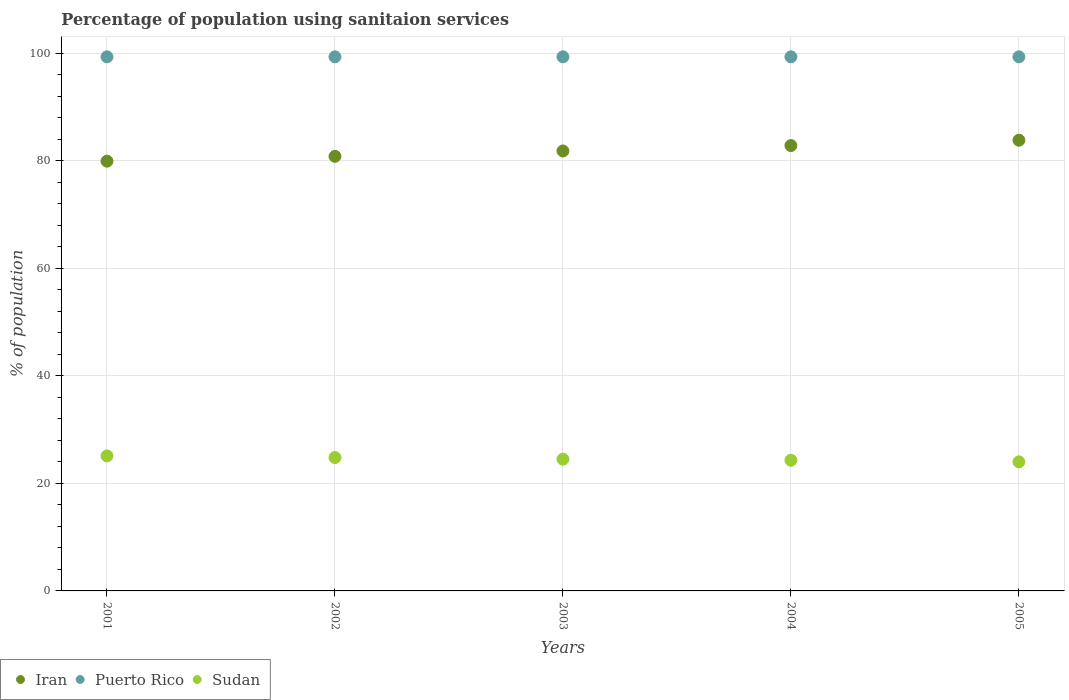Is the number of dotlines equal to the number of legend labels?
Offer a terse response. Yes. What is the percentage of population using sanitaion services in Iran in 2002?
Keep it short and to the point. 80.8. Across all years, what is the maximum percentage of population using sanitaion services in Puerto Rico?
Your response must be concise. 99.3. Across all years, what is the minimum percentage of population using sanitaion services in Puerto Rico?
Provide a short and direct response. 99.3. In which year was the percentage of population using sanitaion services in Iran minimum?
Offer a terse response. 2001. What is the total percentage of population using sanitaion services in Iran in the graph?
Keep it short and to the point. 409.1. What is the difference between the percentage of population using sanitaion services in Sudan in 2002 and the percentage of population using sanitaion services in Puerto Rico in 2005?
Provide a succinct answer. -74.5. What is the average percentage of population using sanitaion services in Sudan per year?
Your answer should be compact. 24.54. In how many years, is the percentage of population using sanitaion services in Iran greater than 36 %?
Offer a very short reply. 5. Is the difference between the percentage of population using sanitaion services in Puerto Rico in 2001 and 2002 greater than the difference between the percentage of population using sanitaion services in Iran in 2001 and 2002?
Your response must be concise. Yes. What is the difference between the highest and the lowest percentage of population using sanitaion services in Puerto Rico?
Your answer should be very brief. 0. In how many years, is the percentage of population using sanitaion services in Sudan greater than the average percentage of population using sanitaion services in Sudan taken over all years?
Keep it short and to the point. 2. Is the sum of the percentage of population using sanitaion services in Sudan in 2004 and 2005 greater than the maximum percentage of population using sanitaion services in Puerto Rico across all years?
Provide a succinct answer. No. Is it the case that in every year, the sum of the percentage of population using sanitaion services in Iran and percentage of population using sanitaion services in Puerto Rico  is greater than the percentage of population using sanitaion services in Sudan?
Your response must be concise. Yes. Does the percentage of population using sanitaion services in Sudan monotonically increase over the years?
Offer a very short reply. No. Is the percentage of population using sanitaion services in Puerto Rico strictly less than the percentage of population using sanitaion services in Sudan over the years?
Your answer should be compact. No. What is the difference between two consecutive major ticks on the Y-axis?
Give a very brief answer. 20. How many legend labels are there?
Make the answer very short. 3. What is the title of the graph?
Your answer should be compact. Percentage of population using sanitaion services. Does "Singapore" appear as one of the legend labels in the graph?
Make the answer very short. No. What is the label or title of the X-axis?
Your answer should be compact. Years. What is the label or title of the Y-axis?
Make the answer very short. % of population. What is the % of population in Iran in 2001?
Make the answer very short. 79.9. What is the % of population in Puerto Rico in 2001?
Keep it short and to the point. 99.3. What is the % of population of Sudan in 2001?
Make the answer very short. 25.1. What is the % of population in Iran in 2002?
Ensure brevity in your answer.  80.8. What is the % of population of Puerto Rico in 2002?
Offer a terse response. 99.3. What is the % of population in Sudan in 2002?
Provide a short and direct response. 24.8. What is the % of population in Iran in 2003?
Ensure brevity in your answer.  81.8. What is the % of population of Puerto Rico in 2003?
Your answer should be compact. 99.3. What is the % of population in Sudan in 2003?
Provide a succinct answer. 24.5. What is the % of population in Iran in 2004?
Your answer should be compact. 82.8. What is the % of population of Puerto Rico in 2004?
Your answer should be very brief. 99.3. What is the % of population in Sudan in 2004?
Your answer should be compact. 24.3. What is the % of population of Iran in 2005?
Give a very brief answer. 83.8. What is the % of population of Puerto Rico in 2005?
Provide a succinct answer. 99.3. Across all years, what is the maximum % of population in Iran?
Give a very brief answer. 83.8. Across all years, what is the maximum % of population in Puerto Rico?
Your answer should be compact. 99.3. Across all years, what is the maximum % of population in Sudan?
Offer a very short reply. 25.1. Across all years, what is the minimum % of population of Iran?
Your answer should be very brief. 79.9. Across all years, what is the minimum % of population of Puerto Rico?
Your answer should be compact. 99.3. What is the total % of population of Iran in the graph?
Ensure brevity in your answer.  409.1. What is the total % of population in Puerto Rico in the graph?
Make the answer very short. 496.5. What is the total % of population in Sudan in the graph?
Your answer should be very brief. 122.7. What is the difference between the % of population in Iran in 2001 and that in 2002?
Ensure brevity in your answer.  -0.9. What is the difference between the % of population of Sudan in 2001 and that in 2003?
Offer a terse response. 0.6. What is the difference between the % of population of Iran in 2001 and that in 2004?
Ensure brevity in your answer.  -2.9. What is the difference between the % of population in Puerto Rico in 2001 and that in 2004?
Offer a very short reply. 0. What is the difference between the % of population in Sudan in 2001 and that in 2004?
Your answer should be compact. 0.8. What is the difference between the % of population in Iran in 2001 and that in 2005?
Give a very brief answer. -3.9. What is the difference between the % of population of Puerto Rico in 2001 and that in 2005?
Your answer should be compact. 0. What is the difference between the % of population of Iran in 2002 and that in 2003?
Keep it short and to the point. -1. What is the difference between the % of population of Sudan in 2002 and that in 2003?
Provide a succinct answer. 0.3. What is the difference between the % of population in Puerto Rico in 2002 and that in 2004?
Provide a short and direct response. 0. What is the difference between the % of population in Puerto Rico in 2002 and that in 2005?
Offer a terse response. 0. What is the difference between the % of population of Puerto Rico in 2003 and that in 2004?
Your answer should be compact. 0. What is the difference between the % of population in Iran in 2003 and that in 2005?
Offer a very short reply. -2. What is the difference between the % of population in Puerto Rico in 2003 and that in 2005?
Give a very brief answer. 0. What is the difference between the % of population in Sudan in 2004 and that in 2005?
Ensure brevity in your answer.  0.3. What is the difference between the % of population in Iran in 2001 and the % of population in Puerto Rico in 2002?
Offer a terse response. -19.4. What is the difference between the % of population in Iran in 2001 and the % of population in Sudan in 2002?
Offer a terse response. 55.1. What is the difference between the % of population in Puerto Rico in 2001 and the % of population in Sudan in 2002?
Offer a very short reply. 74.5. What is the difference between the % of population of Iran in 2001 and the % of population of Puerto Rico in 2003?
Give a very brief answer. -19.4. What is the difference between the % of population in Iran in 2001 and the % of population in Sudan in 2003?
Your answer should be compact. 55.4. What is the difference between the % of population of Puerto Rico in 2001 and the % of population of Sudan in 2003?
Ensure brevity in your answer.  74.8. What is the difference between the % of population in Iran in 2001 and the % of population in Puerto Rico in 2004?
Ensure brevity in your answer.  -19.4. What is the difference between the % of population of Iran in 2001 and the % of population of Sudan in 2004?
Ensure brevity in your answer.  55.6. What is the difference between the % of population in Iran in 2001 and the % of population in Puerto Rico in 2005?
Make the answer very short. -19.4. What is the difference between the % of population in Iran in 2001 and the % of population in Sudan in 2005?
Offer a very short reply. 55.9. What is the difference between the % of population in Puerto Rico in 2001 and the % of population in Sudan in 2005?
Keep it short and to the point. 75.3. What is the difference between the % of population of Iran in 2002 and the % of population of Puerto Rico in 2003?
Provide a succinct answer. -18.5. What is the difference between the % of population of Iran in 2002 and the % of population of Sudan in 2003?
Provide a short and direct response. 56.3. What is the difference between the % of population of Puerto Rico in 2002 and the % of population of Sudan in 2003?
Your response must be concise. 74.8. What is the difference between the % of population of Iran in 2002 and the % of population of Puerto Rico in 2004?
Your answer should be compact. -18.5. What is the difference between the % of population in Iran in 2002 and the % of population in Sudan in 2004?
Ensure brevity in your answer.  56.5. What is the difference between the % of population in Iran in 2002 and the % of population in Puerto Rico in 2005?
Your answer should be very brief. -18.5. What is the difference between the % of population of Iran in 2002 and the % of population of Sudan in 2005?
Keep it short and to the point. 56.8. What is the difference between the % of population of Puerto Rico in 2002 and the % of population of Sudan in 2005?
Offer a very short reply. 75.3. What is the difference between the % of population in Iran in 2003 and the % of population in Puerto Rico in 2004?
Your response must be concise. -17.5. What is the difference between the % of population of Iran in 2003 and the % of population of Sudan in 2004?
Ensure brevity in your answer.  57.5. What is the difference between the % of population of Iran in 2003 and the % of population of Puerto Rico in 2005?
Offer a terse response. -17.5. What is the difference between the % of population in Iran in 2003 and the % of population in Sudan in 2005?
Make the answer very short. 57.8. What is the difference between the % of population of Puerto Rico in 2003 and the % of population of Sudan in 2005?
Give a very brief answer. 75.3. What is the difference between the % of population of Iran in 2004 and the % of population of Puerto Rico in 2005?
Give a very brief answer. -16.5. What is the difference between the % of population of Iran in 2004 and the % of population of Sudan in 2005?
Make the answer very short. 58.8. What is the difference between the % of population in Puerto Rico in 2004 and the % of population in Sudan in 2005?
Give a very brief answer. 75.3. What is the average % of population of Iran per year?
Provide a short and direct response. 81.82. What is the average % of population in Puerto Rico per year?
Your answer should be compact. 99.3. What is the average % of population of Sudan per year?
Offer a very short reply. 24.54. In the year 2001, what is the difference between the % of population of Iran and % of population of Puerto Rico?
Give a very brief answer. -19.4. In the year 2001, what is the difference between the % of population of Iran and % of population of Sudan?
Give a very brief answer. 54.8. In the year 2001, what is the difference between the % of population in Puerto Rico and % of population in Sudan?
Your answer should be compact. 74.2. In the year 2002, what is the difference between the % of population in Iran and % of population in Puerto Rico?
Your response must be concise. -18.5. In the year 2002, what is the difference between the % of population of Iran and % of population of Sudan?
Ensure brevity in your answer.  56. In the year 2002, what is the difference between the % of population in Puerto Rico and % of population in Sudan?
Provide a short and direct response. 74.5. In the year 2003, what is the difference between the % of population in Iran and % of population in Puerto Rico?
Ensure brevity in your answer.  -17.5. In the year 2003, what is the difference between the % of population of Iran and % of population of Sudan?
Your response must be concise. 57.3. In the year 2003, what is the difference between the % of population in Puerto Rico and % of population in Sudan?
Give a very brief answer. 74.8. In the year 2004, what is the difference between the % of population in Iran and % of population in Puerto Rico?
Ensure brevity in your answer.  -16.5. In the year 2004, what is the difference between the % of population in Iran and % of population in Sudan?
Your response must be concise. 58.5. In the year 2005, what is the difference between the % of population of Iran and % of population of Puerto Rico?
Give a very brief answer. -15.5. In the year 2005, what is the difference between the % of population of Iran and % of population of Sudan?
Ensure brevity in your answer.  59.8. In the year 2005, what is the difference between the % of population in Puerto Rico and % of population in Sudan?
Offer a very short reply. 75.3. What is the ratio of the % of population in Iran in 2001 to that in 2002?
Provide a short and direct response. 0.99. What is the ratio of the % of population of Sudan in 2001 to that in 2002?
Offer a very short reply. 1.01. What is the ratio of the % of population of Iran in 2001 to that in 2003?
Make the answer very short. 0.98. What is the ratio of the % of population of Sudan in 2001 to that in 2003?
Provide a succinct answer. 1.02. What is the ratio of the % of population of Iran in 2001 to that in 2004?
Give a very brief answer. 0.96. What is the ratio of the % of population in Sudan in 2001 to that in 2004?
Your response must be concise. 1.03. What is the ratio of the % of population of Iran in 2001 to that in 2005?
Ensure brevity in your answer.  0.95. What is the ratio of the % of population in Puerto Rico in 2001 to that in 2005?
Your response must be concise. 1. What is the ratio of the % of population of Sudan in 2001 to that in 2005?
Give a very brief answer. 1.05. What is the ratio of the % of population of Iran in 2002 to that in 2003?
Ensure brevity in your answer.  0.99. What is the ratio of the % of population in Sudan in 2002 to that in 2003?
Offer a very short reply. 1.01. What is the ratio of the % of population in Iran in 2002 to that in 2004?
Provide a succinct answer. 0.98. What is the ratio of the % of population in Sudan in 2002 to that in 2004?
Your response must be concise. 1.02. What is the ratio of the % of population in Iran in 2002 to that in 2005?
Offer a terse response. 0.96. What is the ratio of the % of population of Sudan in 2002 to that in 2005?
Keep it short and to the point. 1.03. What is the ratio of the % of population of Iran in 2003 to that in 2004?
Keep it short and to the point. 0.99. What is the ratio of the % of population of Puerto Rico in 2003 to that in 2004?
Make the answer very short. 1. What is the ratio of the % of population in Sudan in 2003 to that in 2004?
Offer a very short reply. 1.01. What is the ratio of the % of population in Iran in 2003 to that in 2005?
Your response must be concise. 0.98. What is the ratio of the % of population of Sudan in 2003 to that in 2005?
Give a very brief answer. 1.02. What is the ratio of the % of population of Sudan in 2004 to that in 2005?
Your answer should be very brief. 1.01. What is the difference between the highest and the lowest % of population in Iran?
Offer a very short reply. 3.9. What is the difference between the highest and the lowest % of population in Puerto Rico?
Your response must be concise. 0. What is the difference between the highest and the lowest % of population of Sudan?
Your answer should be compact. 1.1. 